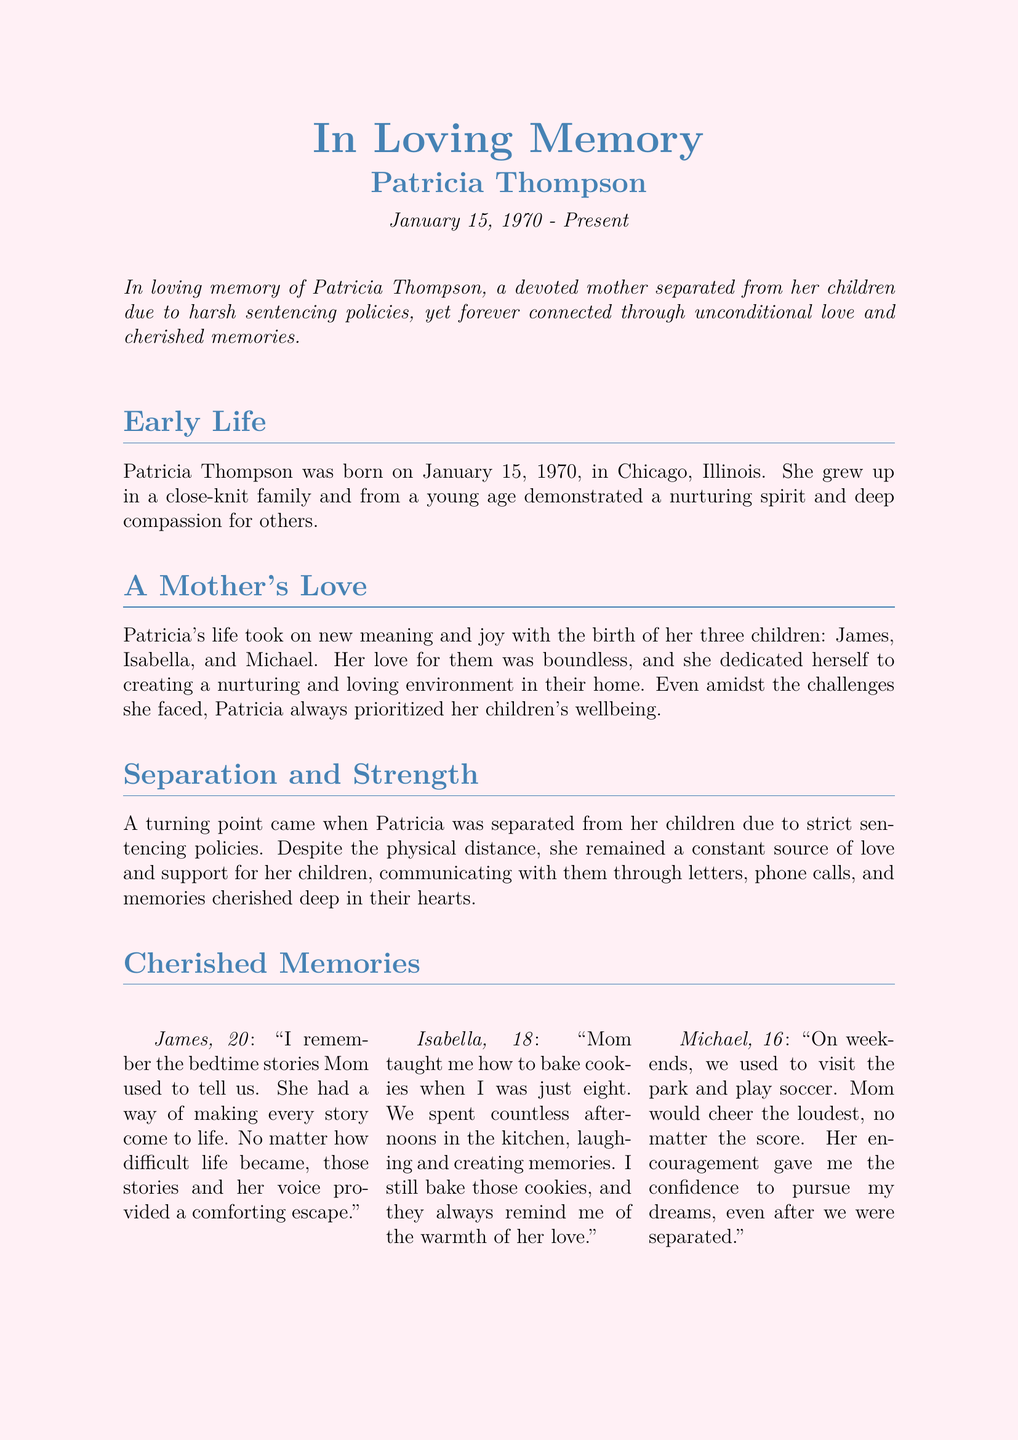what is the name of the individual being remembered? The document is an obituary for Patricia Thompson, who is the subject of the memorial.
Answer: Patricia Thompson when was Patricia Thompson born? The document states her date of birth as January 15, 1970.
Answer: January 15, 1970 how many children did Patricia have? The document mentions that Patricia had three children, named James, Isabella, and Michael.
Answer: three what did James remember about his mother's stories? One of James's cherished memories is about bedtime stories told by his mother, which provided comfort.
Answer: bedtime stories what legacy did Patricia advocate for? The document notes that Patricia advocated for changes in sentencing policies to help prevent family separations.
Answer: sentencing policies how did Patricia maintain her bond with her children despite separation? The document indicates that she communicated through letters, phone calls, and shared memories despite being separated.
Answer: letters and phone calls what did Isabella learn to bake with her mother? According to Isabella's memory, she learned to bake cookies with her mother when she was eight.
Answer: cookies in which city was Patricia Thompson born? The document states that she was born in Chicago, Illinois.
Answer: Chicago, Illinois what sport did Michael play with his mother at the park? The document mentions that Michael and his mom played soccer during their park visits.
Answer: soccer 